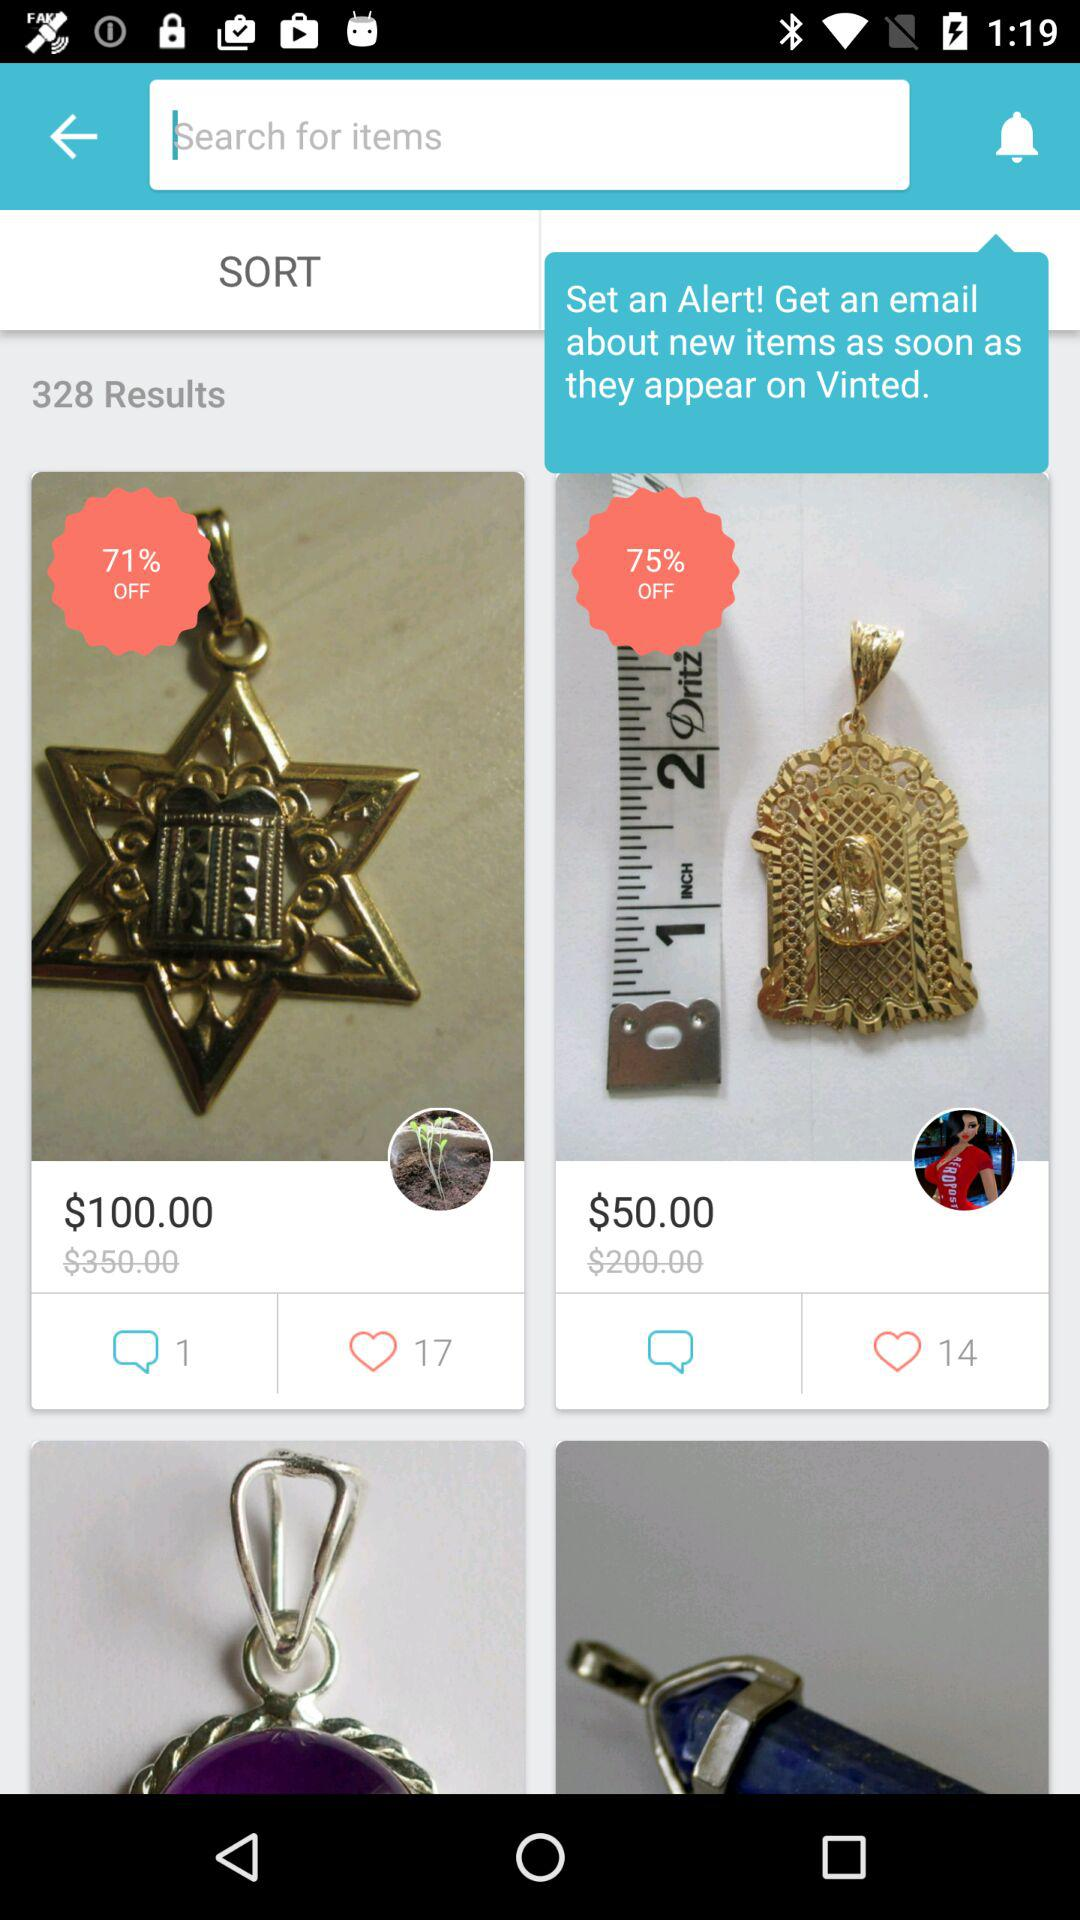How many items have an original price of more than $100?
Answer the question using a single word or phrase. 2 